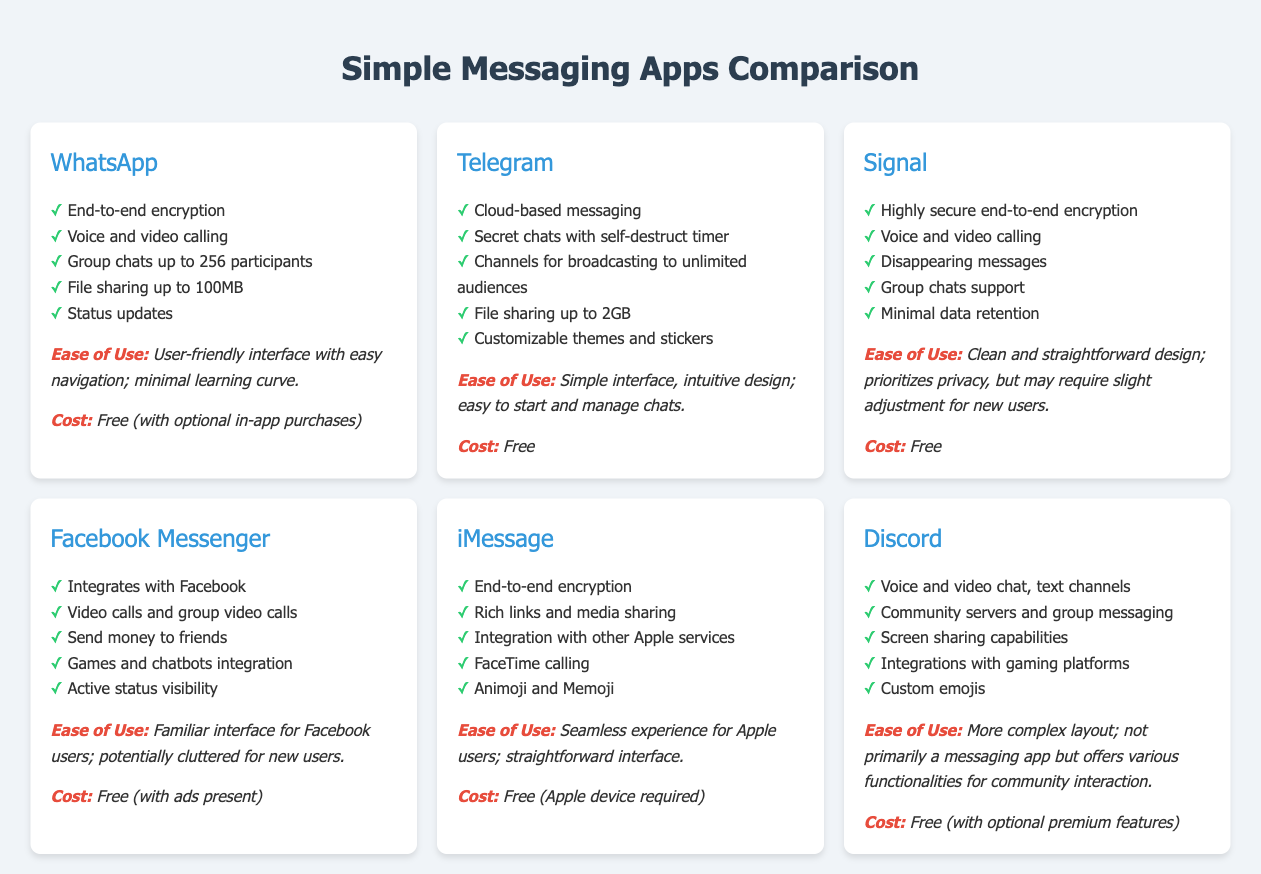What is the name of the first app listed? The first app in the comparison is listed at the top of the document.
Answer: WhatsApp How many participants can join a group chat in WhatsApp? The document mentions that WhatsApp supports group chats up to a certain number of participants.
Answer: 256 What type of encryption does Signal use? The document specifies that Signal uses a certain type of encryption.
Answer: Highly secure end-to-end encryption Which app allows file sharing up to 2GB? The document lists Telegram's file sharing capability specifically for its features.
Answer: Telegram What is the cost of using iMessage? The document clearly states the cost associated with iMessage.
Answer: Free (Apple device required) Which app provides customizable themes and stickers? The document highlights a specific feature of Telegram related to customization.
Answer: Telegram What is a primary drawback mentioned for Discord's interface? The document describes the layout of Discord and mentions a specific user experience aspect.
Answer: More complex layout What is the maximum file size for sharing in WhatsApp? The document details a specific limitation regarding file sharing in WhatsApp.
Answer: 100MB How does the interface of Facebook Messenger compare for new users? The document provides an assessment of Facebook Messenger's interface from a new user's perspective.
Answer: Potentially cluttered for new users 